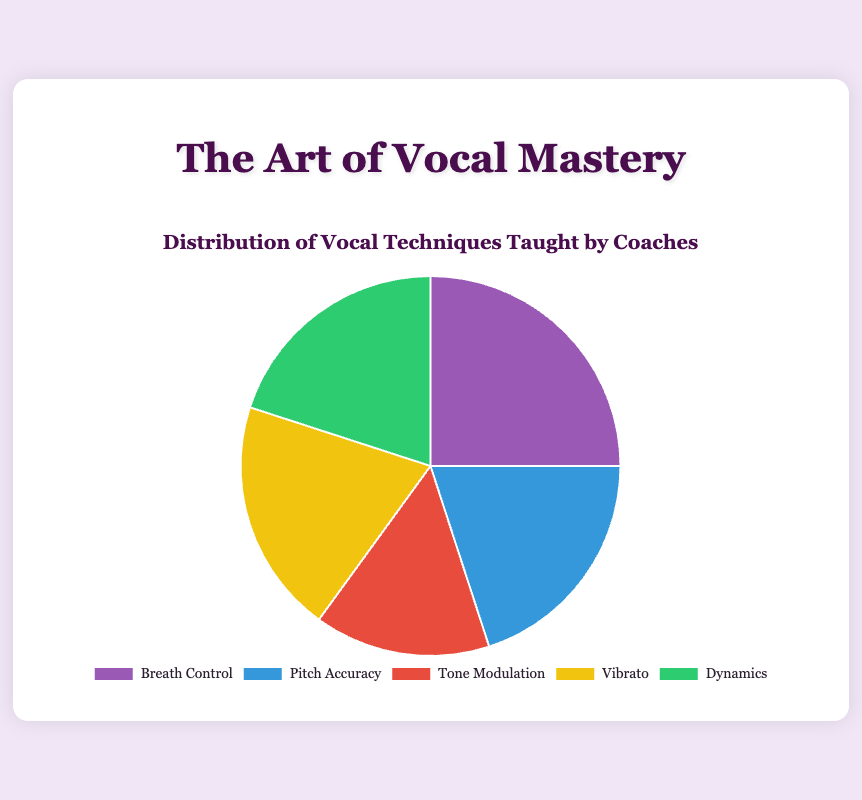Which vocal technique is taught the most according to the chart? The section of the pie chart with the largest percentage represents the most taught vocal technique. According to the chart, Breath Control has the largest percentage at 25%.
Answer: Breath Control Which three vocal techniques are taught equally according to the chart? Look for sections of the pie chart that have the same size and percentage value. Pitch Accuracy, Vibrato, and Dynamics each have a percentage of 20%.
Answer: Pitch Accuracy, Vibrato, Dynamics What is the total percentage of the techniques taught less than 20%? Identify the techniques with a percentage less than 20% and sum them up. Only Tone Modulation falls below 20%, and its percentage is 15%.
Answer: 15% How much greater is the percentage of Breath Control compared to Tone Modulation? Subtract the percentage of Tone Modulation from the percentage of Breath Control. Breath Control is 25% and Tone Modulation is 15%, so 25% - 15% = 10%.
Answer: 10% Which vocal technique is represented by the green segment of the pie chart? Identify the technique associated with the green segment by examining the visual color legend. The green segment corresponds to Dynamics.
Answer: Dynamics If you group Breath Control with all other techniques together, what is the combined percentage of the other techniques? Subtract the percentage of Breath Control from 100% to get the combined percentage of the remaining techniques. 100% - 25% = 75%.
Answer: 75% What percentage of techniques are taught more frequently than Tone Modulation? Identify all techniques with a percentage greater than Tone Modulation (15%). Breath Control (25%), Pitch Accuracy (20%), Vibrato (20%), and Dynamics (20%) are all greater than 15%. Sum their percentages: 25 + 20 + 20 + 20 = 85%.
Answer: 85% Is the percentage of Pitch Accuracy greater than or equal to that of Vibrato? Compare the percentage values of Pitch Accuracy and Vibrato. Both have a percentage of 20%, so they are equal.
Answer: Equal What is the average percentage of all the vocal techniques taught? Sum all the percentages and divide by the number of techniques. (25 + 20 + 15 + 20 + 20) / 5 = 100 / 5 = 20%.
Answer: 20% 